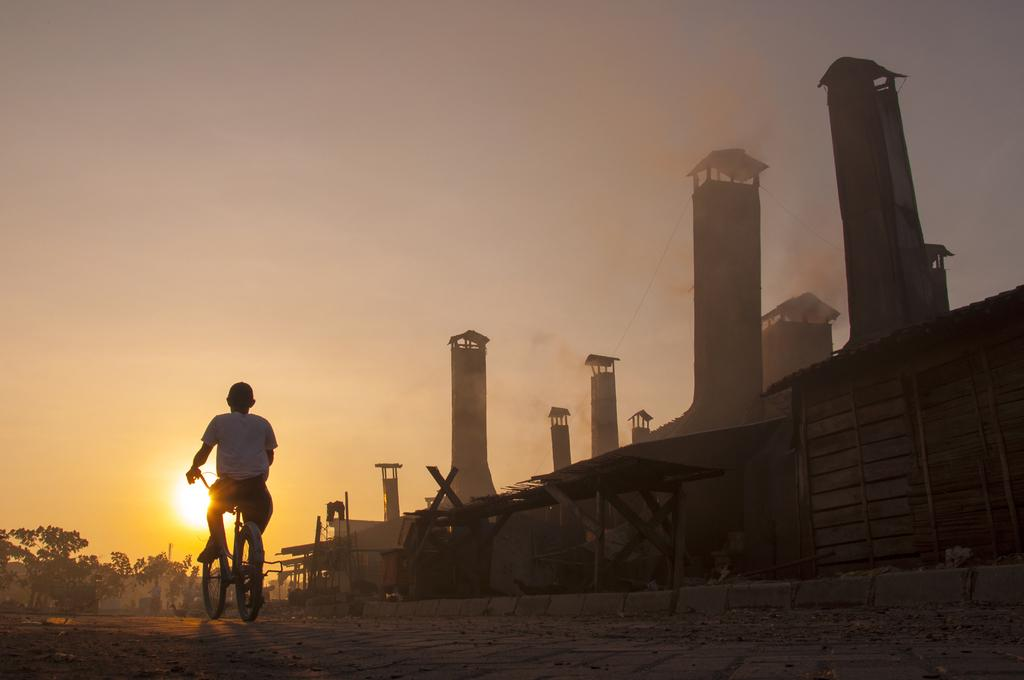What is the person on the left side of the image doing? There is a person riding a bicycle on the left side of the image. What can be seen on the right side of the image? There are towers and a fence on the right side of the image. What is visible in the background of the image? There are trees and the sky in the background of the image. Can the sun be seen in the sky? Yes, the sun is observable in the sky. What type of pancake is the person eating while riding the bicycle in the image? There is no pancake present in the image; the person is riding a bicycle. What color is the vest worn by the insect in the image? There is no insect or vest present in the image. 